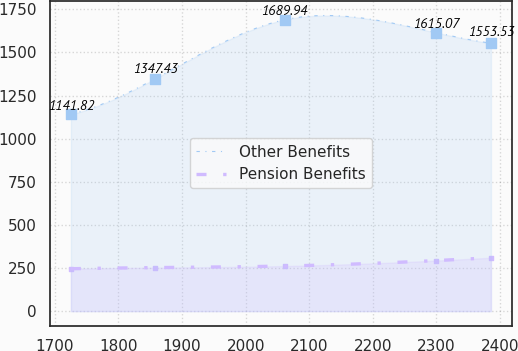Convert chart to OTSL. <chart><loc_0><loc_0><loc_500><loc_500><line_chart><ecel><fcel>Other Benefits<fcel>Pension Benefits<nl><fcel>1725.25<fcel>1141.82<fcel>246.02<nl><fcel>1857.66<fcel>1347.43<fcel>252.4<nl><fcel>2061.5<fcel>1689.94<fcel>261.64<nl><fcel>2299.86<fcel>1615.07<fcel>293.33<nl><fcel>2385.67<fcel>1553.53<fcel>309.8<nl></chart> 